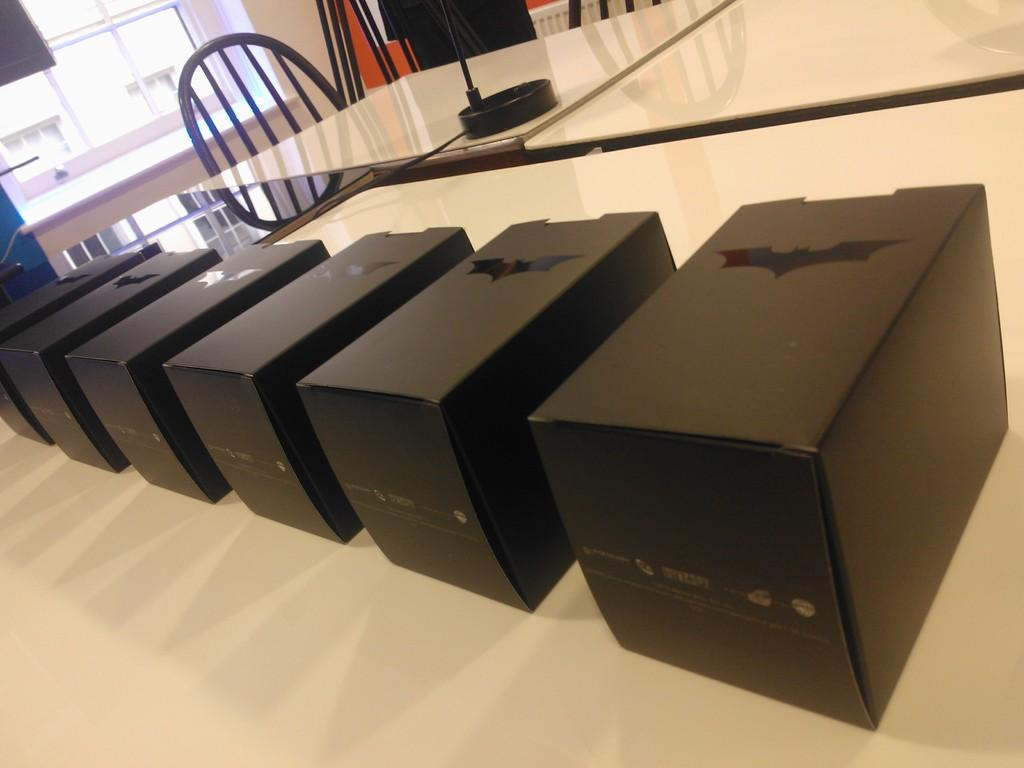What color are the boxes on the table in the image? The boxes on the table are black in color. What furniture is located near the table? There are chairs beside the table in the image. What can be seen in the background of the image? There is a window in the background of the image. What type of patch is sewn onto the chair in the image? There is no patch visible on the chairs in the image. How does the texture of the boxes feel in the image? The texture of the boxes cannot be determined from the image alone, as it is a 2D representation. 